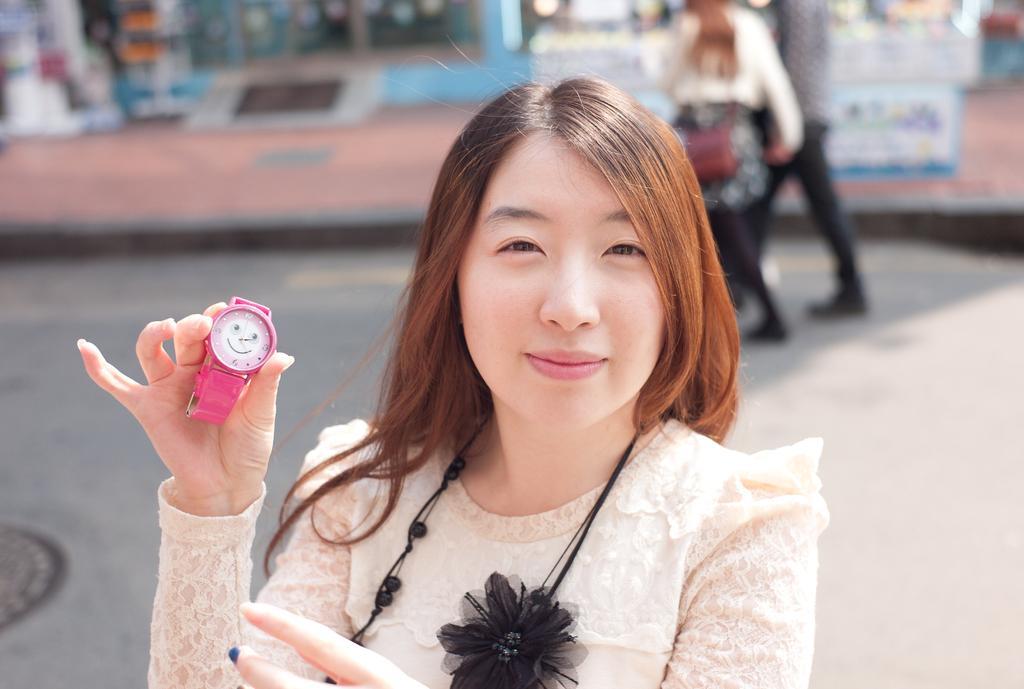In one or two sentences, can you explain what this image depicts? In this image there is a woman with a smile on her face is holding a wrist watch, behind her there is a couple walking on the road. 